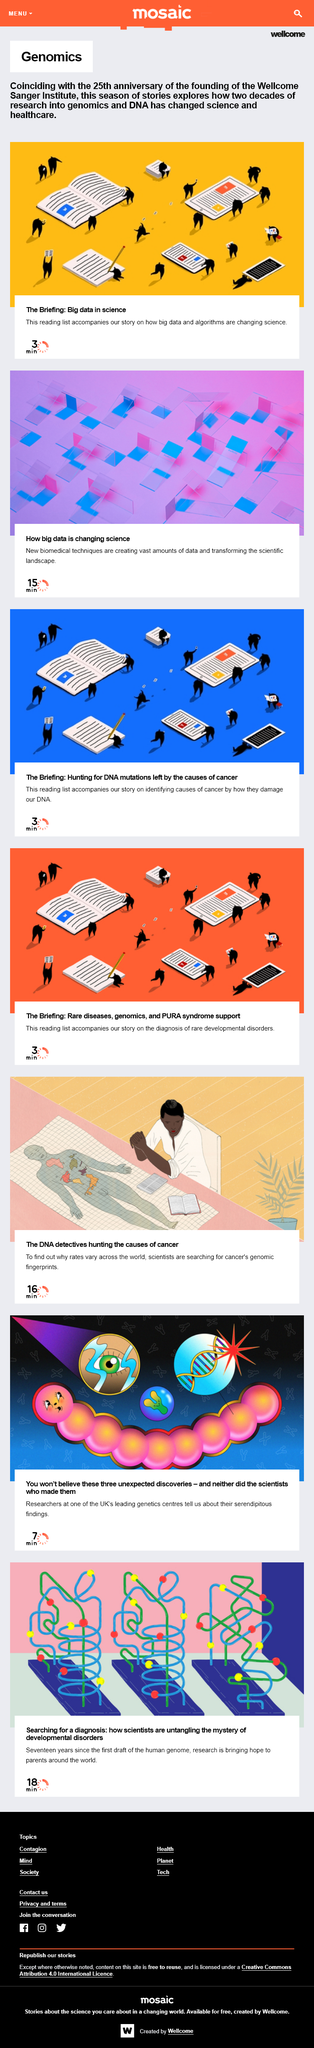Give some essential details in this illustration. Yes, both articles refer to big data changing or transforming science. The video is three minutes long. The articles are about genomics. 